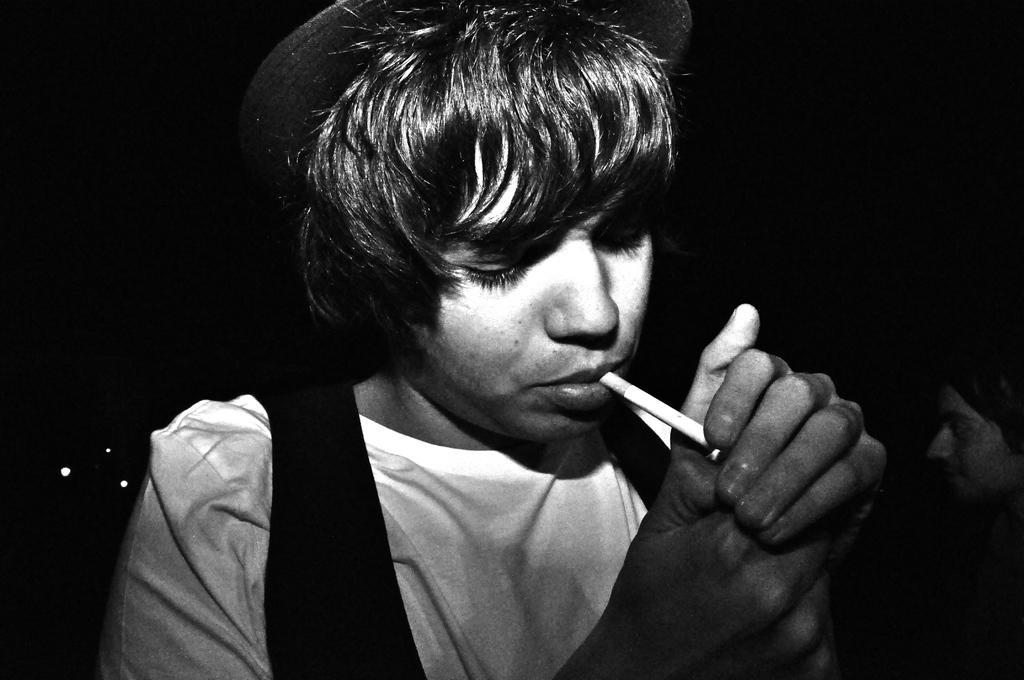Can you describe this image briefly? In this picture there is a man wore hat and smoking. In the background of the image it is dark and we can see a person. 